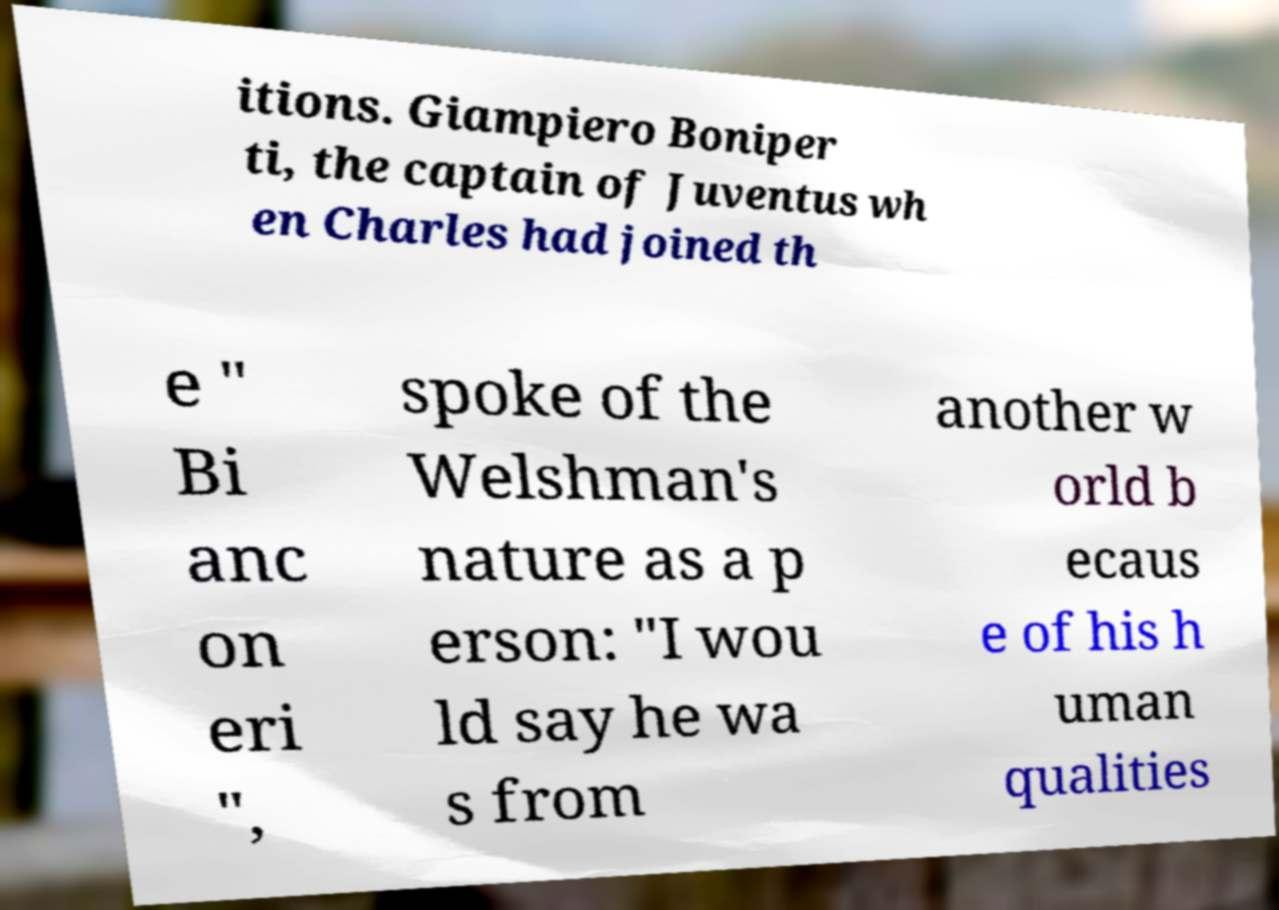Could you extract and type out the text from this image? itions. Giampiero Boniper ti, the captain of Juventus wh en Charles had joined th e " Bi anc on eri ", spoke of the Welshman's nature as a p erson: "I wou ld say he wa s from another w orld b ecaus e of his h uman qualities 